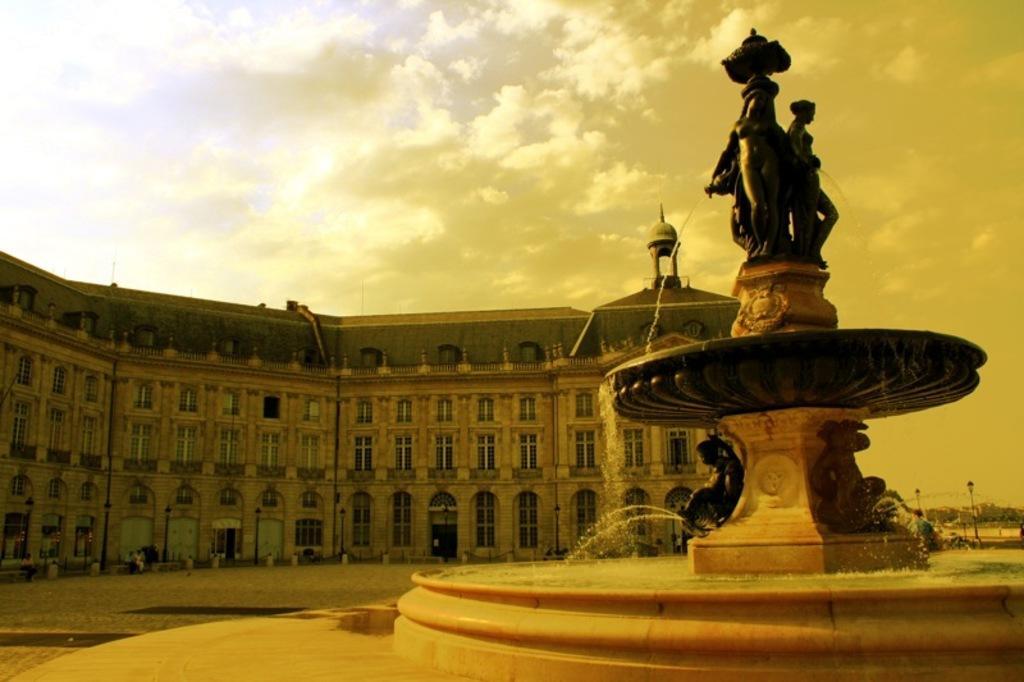Describe this image in one or two sentences. In this picture we can see statues, fountain, water, poles, building with windows, trees, road and some people sitting on benches and in the background we can see the sky with clouds. 